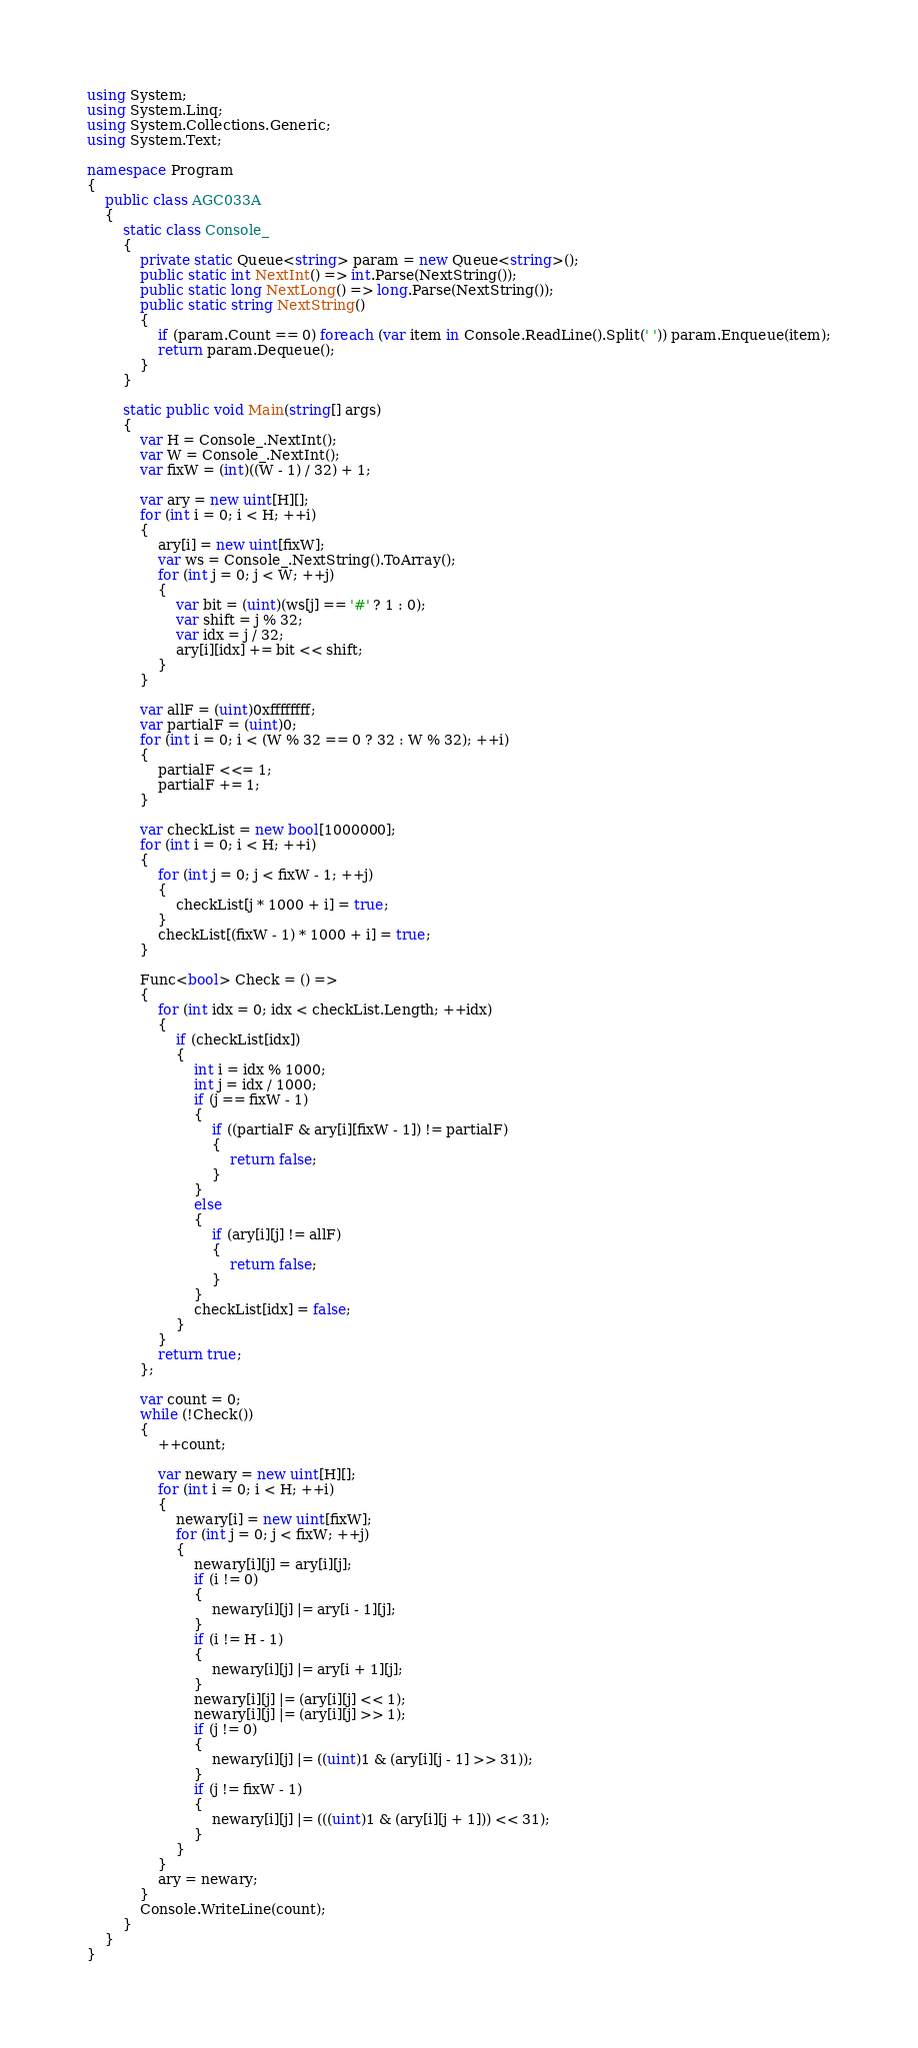Convert code to text. <code><loc_0><loc_0><loc_500><loc_500><_C#_>using System;
using System.Linq;
using System.Collections.Generic;
using System.Text;

namespace Program
{
    public class AGC033A
    {
        static class Console_
        {
            private static Queue<string> param = new Queue<string>();
            public static int NextInt() => int.Parse(NextString());
            public static long NextLong() => long.Parse(NextString());
            public static string NextString()
            {
                if (param.Count == 0) foreach (var item in Console.ReadLine().Split(' ')) param.Enqueue(item);
                return param.Dequeue();
            }
        }

        static public void Main(string[] args)
        {
            var H = Console_.NextInt();
            var W = Console_.NextInt();
            var fixW = (int)((W - 1) / 32) + 1;

            var ary = new uint[H][];
            for (int i = 0; i < H; ++i)
            {
                ary[i] = new uint[fixW];
                var ws = Console_.NextString().ToArray();
                for (int j = 0; j < W; ++j)
                {
                    var bit = (uint)(ws[j] == '#' ? 1 : 0);
                    var shift = j % 32;
                    var idx = j / 32;
                    ary[i][idx] += bit << shift;
                }
            }

            var allF = (uint)0xffffffff;
            var partialF = (uint)0;
            for (int i = 0; i < (W % 32 == 0 ? 32 : W % 32); ++i)
            {
                partialF <<= 1;
                partialF += 1;
            }

            var checkList = new bool[1000000];
            for (int i = 0; i < H; ++i)
            {
                for (int j = 0; j < fixW - 1; ++j)
                {
                    checkList[j * 1000 + i] = true;
                }
                checkList[(fixW - 1) * 1000 + i] = true;
            }

            Func<bool> Check = () =>
            {
                for (int idx = 0; idx < checkList.Length; ++idx)
                {
                    if (checkList[idx])
                    {
                        int i = idx % 1000;
                        int j = idx / 1000;
                        if (j == fixW - 1)
                        {
                            if ((partialF & ary[i][fixW - 1]) != partialF)
                            {
                                return false;
                            }
                        }
                        else
                        {
                            if (ary[i][j] != allF)
                            {
                                return false;
                            }
                        }
                        checkList[idx] = false;
                    }
                }
                return true;
            };

            var count = 0;
            while (!Check())
            {
                ++count;

                var newary = new uint[H][];
                for (int i = 0; i < H; ++i)
                {
                    newary[i] = new uint[fixW];
                    for (int j = 0; j < fixW; ++j)
                    {
                        newary[i][j] = ary[i][j];
                        if (i != 0)
                        {
                            newary[i][j] |= ary[i - 1][j];
                        }
                        if (i != H - 1)
                        {
                            newary[i][j] |= ary[i + 1][j];
                        }
                        newary[i][j] |= (ary[i][j] << 1);
                        newary[i][j] |= (ary[i][j] >> 1);
                        if (j != 0)
                        {
                            newary[i][j] |= ((uint)1 & (ary[i][j - 1] >> 31));
                        }
                        if (j != fixW - 1)
                        {
                            newary[i][j] |= (((uint)1 & (ary[i][j + 1])) << 31);
                        }
                    }
                }
                ary = newary;
            }
            Console.WriteLine(count);
        }
    }
}
</code> 